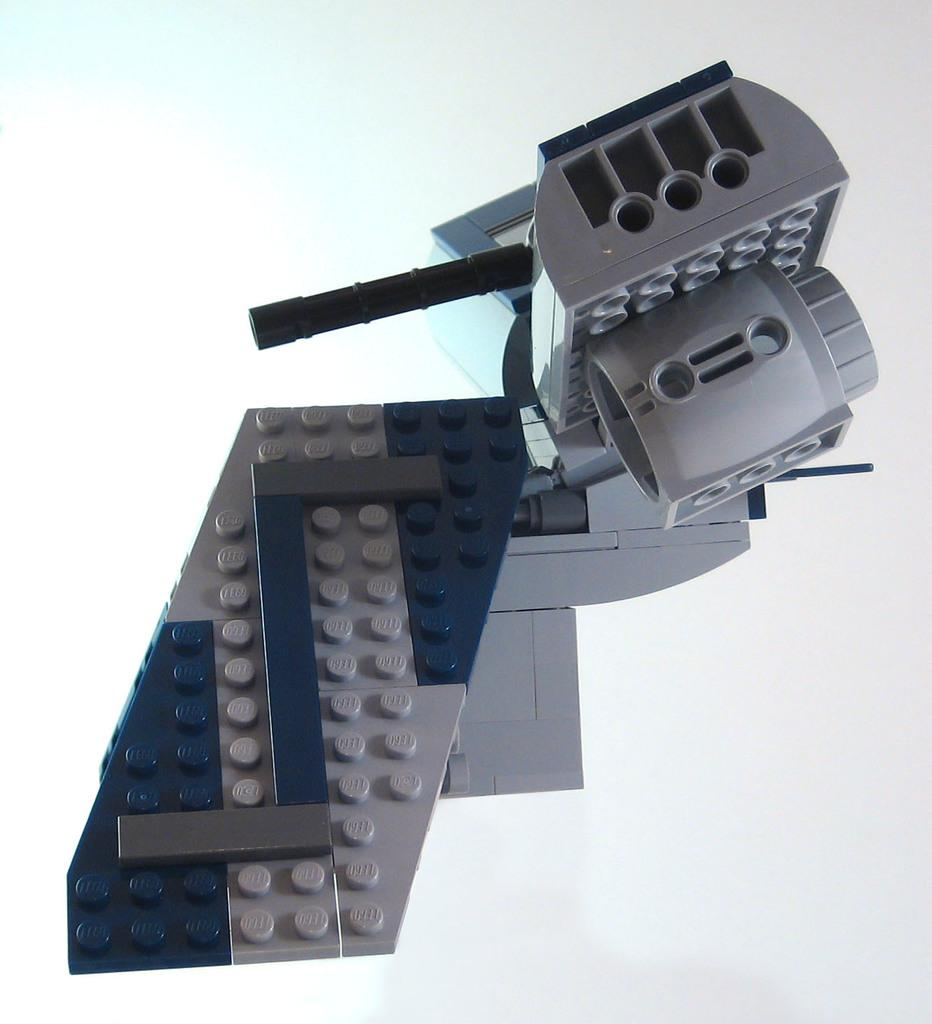What object can be seen in the image? There is a toy in the image. Can you describe the colors of the toy? The toy has a grey and purple color. What type of harmony can be heard in the image? There is no sound or music present in the image, so it is not possible to determine if there is any harmony. 